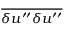Convert formula to latex. <formula><loc_0><loc_0><loc_500><loc_500>\overline { { { \delta u ^ { \prime \prime } \delta u ^ { \prime \prime } } } }</formula> 